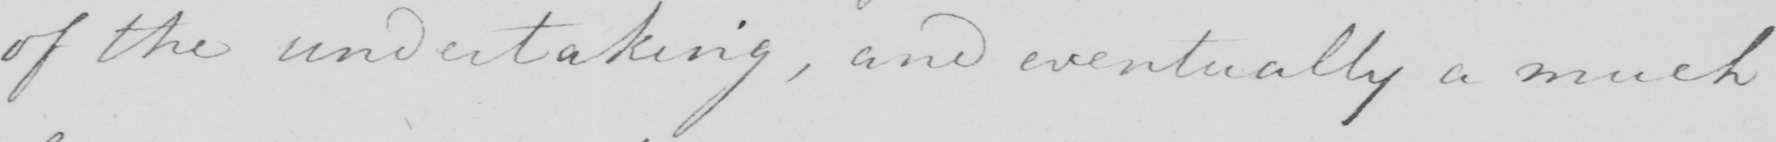Please provide the text content of this handwritten line. of the undertaking , and eventually a much 